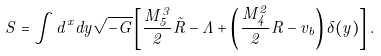<formula> <loc_0><loc_0><loc_500><loc_500>S = \int d ^ { x } d y \sqrt { - G } \left [ \frac { M _ { 5 } ^ { 3 } } { 2 } \tilde { R } - \Lambda + \left ( \frac { M _ { 4 } ^ { 2 } } { 2 } R - v _ { b } \right ) \delta ( y ) \right ] .</formula> 